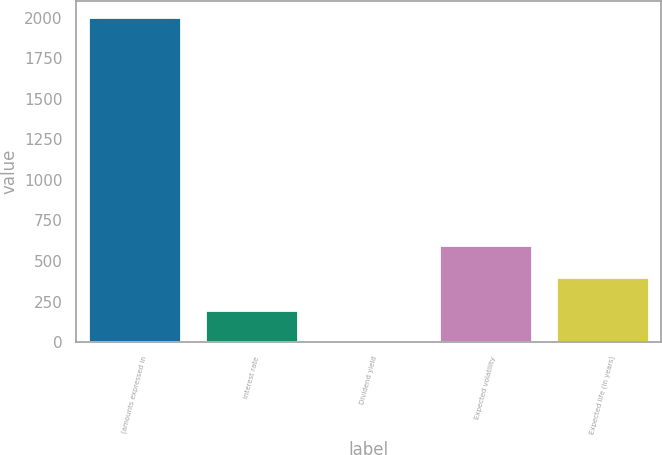Convert chart to OTSL. <chart><loc_0><loc_0><loc_500><loc_500><bar_chart><fcel>(amounts expressed in<fcel>Interest rate<fcel>Dividend yield<fcel>Expected volatility<fcel>Expected life (in years)<nl><fcel>2003<fcel>200.64<fcel>0.38<fcel>601.16<fcel>400.9<nl></chart> 